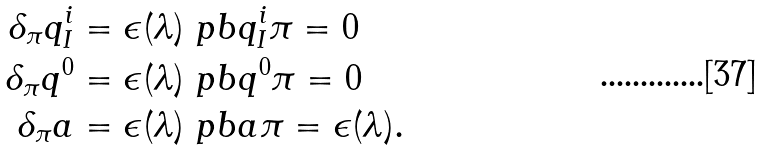<formula> <loc_0><loc_0><loc_500><loc_500>\delta _ { \pi } q ^ { i } _ { I } & = \epsilon ( \lambda ) \ p b { q ^ { i } _ { I } } { \pi } = 0 \\ \delta _ { \pi } q ^ { 0 } & = \epsilon ( \lambda ) \ p b { q ^ { 0 } } { \pi } = 0 \\ \delta _ { \pi } a & = \epsilon ( \lambda ) \ p b { a } { \pi } = \epsilon ( \lambda ) .</formula> 